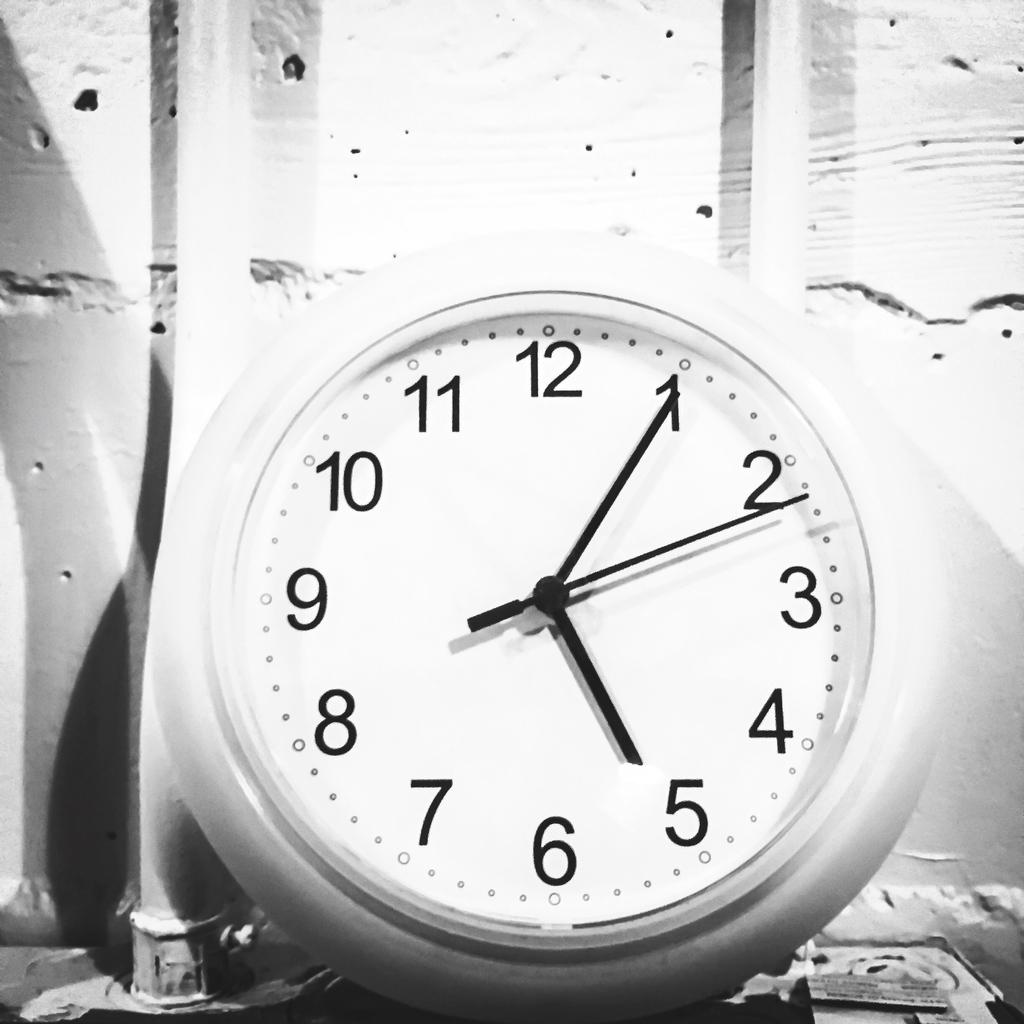Provide a one-sentence caption for the provided image. Black and white clock photo reads 5:05 and 11 seconds. 